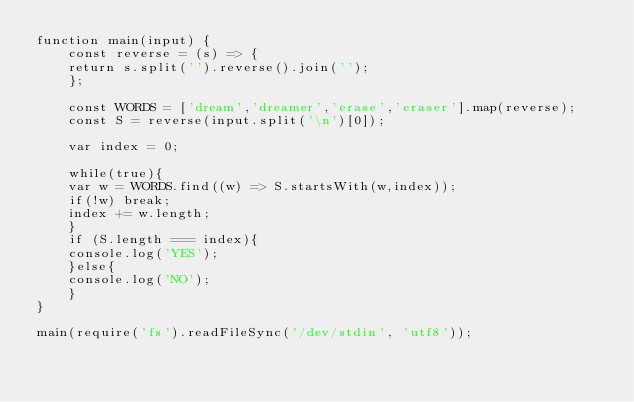Convert code to text. <code><loc_0><loc_0><loc_500><loc_500><_JavaScript_>function main(input) {
    const reverse = (s) => {
	return s.split('').reverse().join('');
    };

    const WORDS = ['dream','dreamer','erase','eraser'].map(reverse);
    const S = reverse(input.split('\n')[0]);

    var index = 0;

    while(true){
	var w = WORDS.find((w) => S.startsWith(w,index));
	if(!w) break;
	index += w.length;
    }
    if (S.length === index){
	console.log('YES');
    }else{
	console.log('NO');
    }
}

main(require('fs').readFileSync('/dev/stdin', 'utf8'));
</code> 